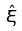<formula> <loc_0><loc_0><loc_500><loc_500>\hat { \xi }</formula> 